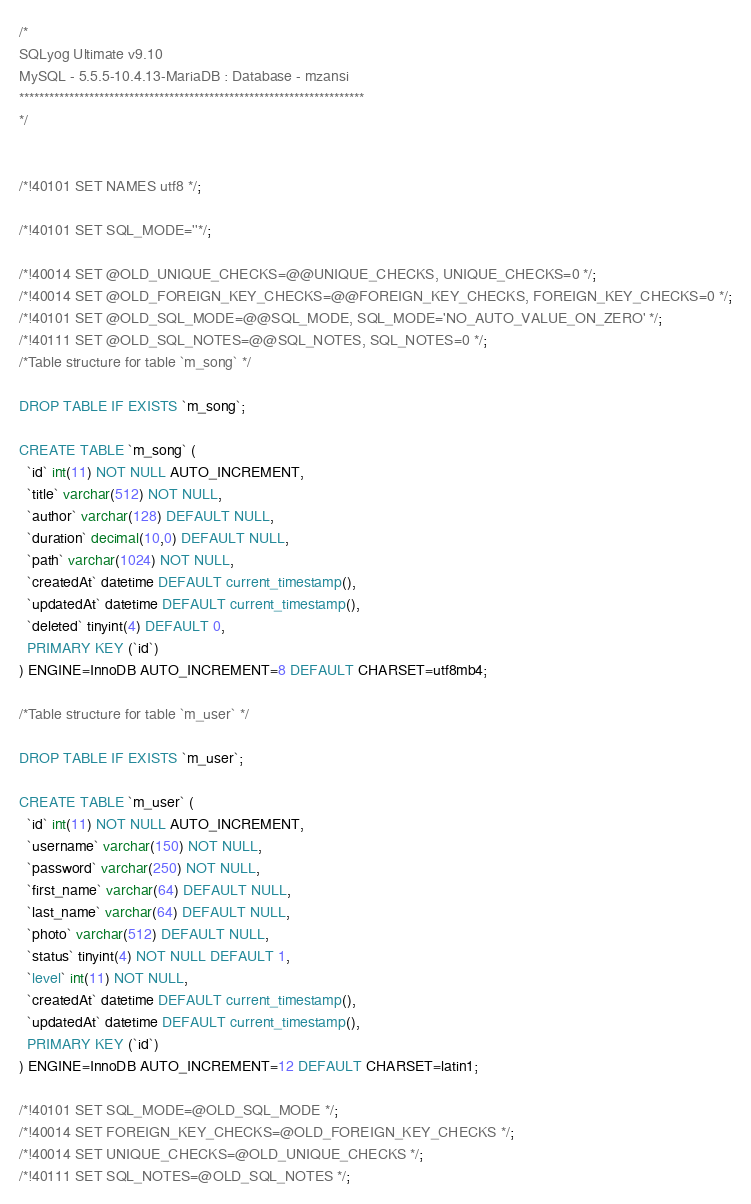<code> <loc_0><loc_0><loc_500><loc_500><_SQL_>/*
SQLyog Ultimate v9.10 
MySQL - 5.5.5-10.4.13-MariaDB : Database - mzansi
*********************************************************************
*/

/*!40101 SET NAMES utf8 */;

/*!40101 SET SQL_MODE=''*/;

/*!40014 SET @OLD_UNIQUE_CHECKS=@@UNIQUE_CHECKS, UNIQUE_CHECKS=0 */;
/*!40014 SET @OLD_FOREIGN_KEY_CHECKS=@@FOREIGN_KEY_CHECKS, FOREIGN_KEY_CHECKS=0 */;
/*!40101 SET @OLD_SQL_MODE=@@SQL_MODE, SQL_MODE='NO_AUTO_VALUE_ON_ZERO' */;
/*!40111 SET @OLD_SQL_NOTES=@@SQL_NOTES, SQL_NOTES=0 */;
/*Table structure for table `m_song` */

DROP TABLE IF EXISTS `m_song`;

CREATE TABLE `m_song` (
  `id` int(11) NOT NULL AUTO_INCREMENT,
  `title` varchar(512) NOT NULL,
  `author` varchar(128) DEFAULT NULL,
  `duration` decimal(10,0) DEFAULT NULL,
  `path` varchar(1024) NOT NULL,
  `createdAt` datetime DEFAULT current_timestamp(),
  `updatedAt` datetime DEFAULT current_timestamp(),
  `deleted` tinyint(4) DEFAULT 0,
  PRIMARY KEY (`id`)
) ENGINE=InnoDB AUTO_INCREMENT=8 DEFAULT CHARSET=utf8mb4;

/*Table structure for table `m_user` */

DROP TABLE IF EXISTS `m_user`;

CREATE TABLE `m_user` (
  `id` int(11) NOT NULL AUTO_INCREMENT,
  `username` varchar(150) NOT NULL,
  `password` varchar(250) NOT NULL,
  `first_name` varchar(64) DEFAULT NULL,
  `last_name` varchar(64) DEFAULT NULL,
  `photo` varchar(512) DEFAULT NULL,
  `status` tinyint(4) NOT NULL DEFAULT 1,
  `level` int(11) NOT NULL,
  `createdAt` datetime DEFAULT current_timestamp(),
  `updatedAt` datetime DEFAULT current_timestamp(),
  PRIMARY KEY (`id`)
) ENGINE=InnoDB AUTO_INCREMENT=12 DEFAULT CHARSET=latin1;

/*!40101 SET SQL_MODE=@OLD_SQL_MODE */;
/*!40014 SET FOREIGN_KEY_CHECKS=@OLD_FOREIGN_KEY_CHECKS */;
/*!40014 SET UNIQUE_CHECKS=@OLD_UNIQUE_CHECKS */;
/*!40111 SET SQL_NOTES=@OLD_SQL_NOTES */;
</code> 